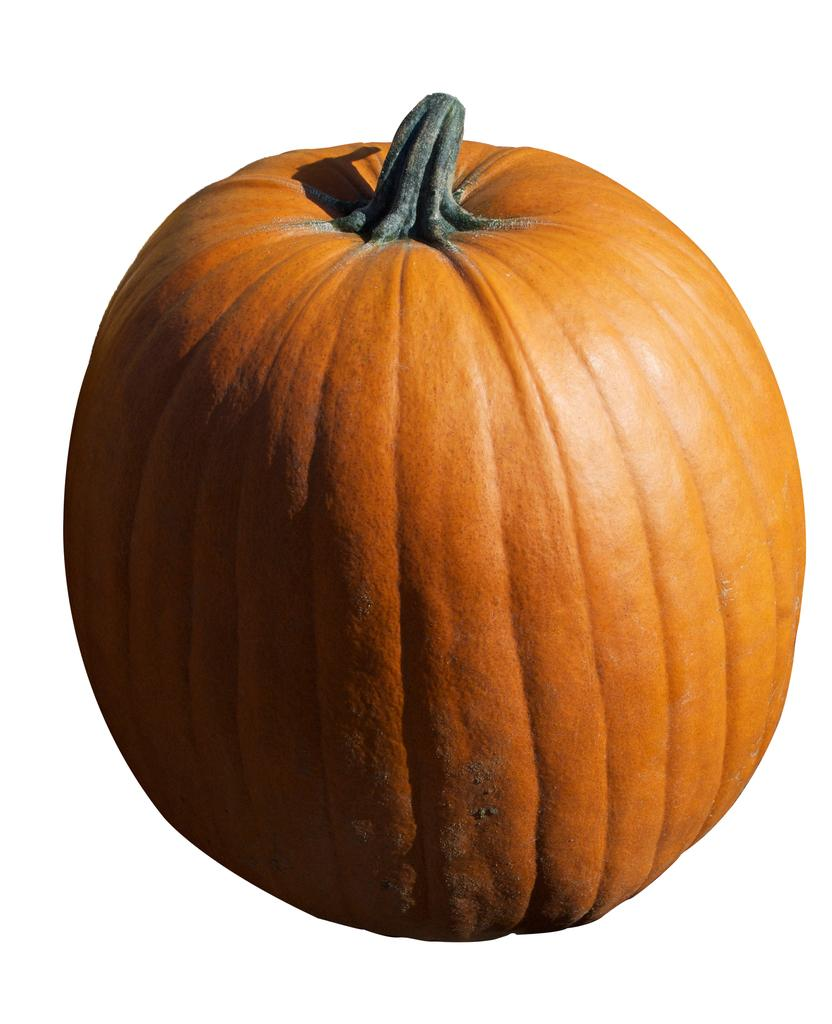What is the main object in the picture? There is a pumpkin in the picture. What is the color of the surface on which the pumpkin is placed? The picture has a white surface. What type of art can be seen on the coast in the image? There is no art or coast present in the image; it features a pumpkin on a white surface. How many eggs are visible in the image? There are no eggs present in the image. 